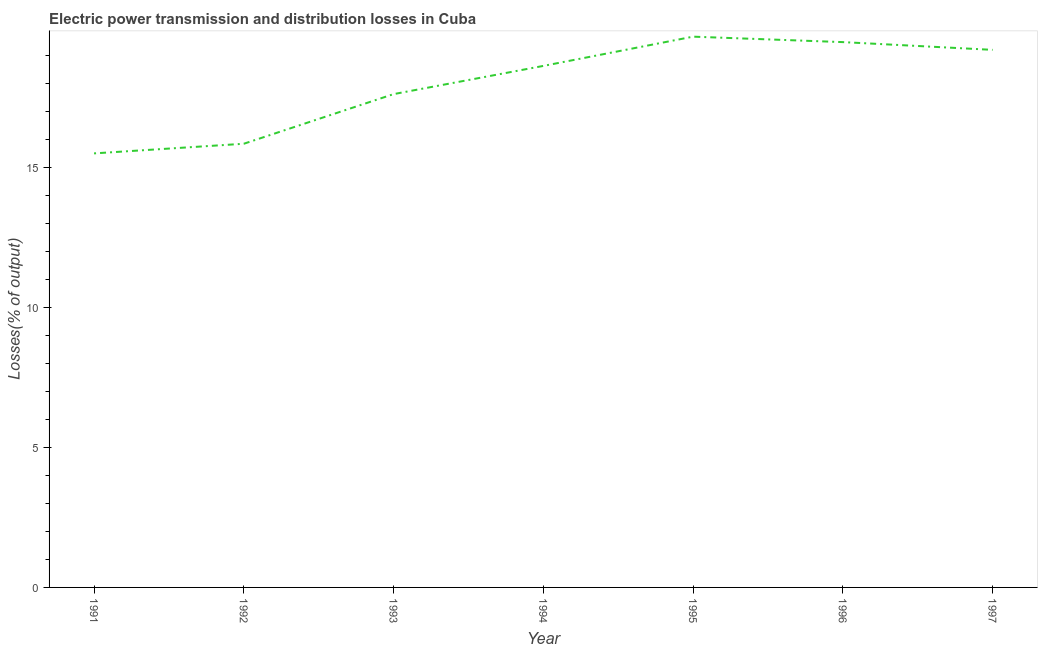What is the electric power transmission and distribution losses in 1993?
Your response must be concise. 17.61. Across all years, what is the maximum electric power transmission and distribution losses?
Make the answer very short. 19.66. Across all years, what is the minimum electric power transmission and distribution losses?
Make the answer very short. 15.49. In which year was the electric power transmission and distribution losses maximum?
Give a very brief answer. 1995. In which year was the electric power transmission and distribution losses minimum?
Give a very brief answer. 1991. What is the sum of the electric power transmission and distribution losses?
Your answer should be compact. 125.85. What is the difference between the electric power transmission and distribution losses in 1994 and 1996?
Provide a succinct answer. -0.85. What is the average electric power transmission and distribution losses per year?
Offer a very short reply. 17.98. What is the median electric power transmission and distribution losses?
Provide a short and direct response. 18.61. Do a majority of the years between 1995 and 1993 (inclusive) have electric power transmission and distribution losses greater than 15 %?
Ensure brevity in your answer.  No. What is the ratio of the electric power transmission and distribution losses in 1993 to that in 1996?
Provide a succinct answer. 0.9. Is the electric power transmission and distribution losses in 1994 less than that in 1997?
Make the answer very short. Yes. What is the difference between the highest and the second highest electric power transmission and distribution losses?
Offer a terse response. 0.19. What is the difference between the highest and the lowest electric power transmission and distribution losses?
Make the answer very short. 4.17. How many lines are there?
Give a very brief answer. 1. Are the values on the major ticks of Y-axis written in scientific E-notation?
Provide a succinct answer. No. Does the graph contain any zero values?
Ensure brevity in your answer.  No. Does the graph contain grids?
Offer a terse response. No. What is the title of the graph?
Keep it short and to the point. Electric power transmission and distribution losses in Cuba. What is the label or title of the X-axis?
Provide a short and direct response. Year. What is the label or title of the Y-axis?
Your response must be concise. Losses(% of output). What is the Losses(% of output) of 1991?
Ensure brevity in your answer.  15.49. What is the Losses(% of output) in 1992?
Make the answer very short. 15.83. What is the Losses(% of output) of 1993?
Your answer should be compact. 17.61. What is the Losses(% of output) of 1994?
Your answer should be very brief. 18.61. What is the Losses(% of output) of 1995?
Make the answer very short. 19.66. What is the Losses(% of output) of 1996?
Offer a terse response. 19.46. What is the Losses(% of output) of 1997?
Provide a short and direct response. 19.19. What is the difference between the Losses(% of output) in 1991 and 1992?
Provide a short and direct response. -0.34. What is the difference between the Losses(% of output) in 1991 and 1993?
Give a very brief answer. -2.12. What is the difference between the Losses(% of output) in 1991 and 1994?
Provide a short and direct response. -3.12. What is the difference between the Losses(% of output) in 1991 and 1995?
Offer a terse response. -4.17. What is the difference between the Losses(% of output) in 1991 and 1996?
Make the answer very short. -3.97. What is the difference between the Losses(% of output) in 1991 and 1997?
Your answer should be very brief. -3.7. What is the difference between the Losses(% of output) in 1992 and 1993?
Offer a very short reply. -1.77. What is the difference between the Losses(% of output) in 1992 and 1994?
Offer a terse response. -2.78. What is the difference between the Losses(% of output) in 1992 and 1995?
Keep it short and to the point. -3.82. What is the difference between the Losses(% of output) in 1992 and 1996?
Your answer should be compact. -3.63. What is the difference between the Losses(% of output) in 1992 and 1997?
Keep it short and to the point. -3.35. What is the difference between the Losses(% of output) in 1993 and 1994?
Give a very brief answer. -1.01. What is the difference between the Losses(% of output) in 1993 and 1995?
Ensure brevity in your answer.  -2.05. What is the difference between the Losses(% of output) in 1993 and 1996?
Offer a very short reply. -1.86. What is the difference between the Losses(% of output) in 1993 and 1997?
Offer a very short reply. -1.58. What is the difference between the Losses(% of output) in 1994 and 1995?
Give a very brief answer. -1.04. What is the difference between the Losses(% of output) in 1994 and 1996?
Keep it short and to the point. -0.85. What is the difference between the Losses(% of output) in 1994 and 1997?
Provide a short and direct response. -0.57. What is the difference between the Losses(% of output) in 1995 and 1996?
Make the answer very short. 0.19. What is the difference between the Losses(% of output) in 1995 and 1997?
Offer a very short reply. 0.47. What is the difference between the Losses(% of output) in 1996 and 1997?
Keep it short and to the point. 0.28. What is the ratio of the Losses(% of output) in 1991 to that in 1992?
Offer a very short reply. 0.98. What is the ratio of the Losses(% of output) in 1991 to that in 1994?
Provide a short and direct response. 0.83. What is the ratio of the Losses(% of output) in 1991 to that in 1995?
Your response must be concise. 0.79. What is the ratio of the Losses(% of output) in 1991 to that in 1996?
Provide a short and direct response. 0.8. What is the ratio of the Losses(% of output) in 1991 to that in 1997?
Offer a very short reply. 0.81. What is the ratio of the Losses(% of output) in 1992 to that in 1993?
Your answer should be compact. 0.9. What is the ratio of the Losses(% of output) in 1992 to that in 1994?
Your answer should be compact. 0.85. What is the ratio of the Losses(% of output) in 1992 to that in 1995?
Offer a very short reply. 0.81. What is the ratio of the Losses(% of output) in 1992 to that in 1996?
Your response must be concise. 0.81. What is the ratio of the Losses(% of output) in 1992 to that in 1997?
Make the answer very short. 0.82. What is the ratio of the Losses(% of output) in 1993 to that in 1994?
Offer a very short reply. 0.95. What is the ratio of the Losses(% of output) in 1993 to that in 1995?
Ensure brevity in your answer.  0.9. What is the ratio of the Losses(% of output) in 1993 to that in 1996?
Provide a succinct answer. 0.91. What is the ratio of the Losses(% of output) in 1993 to that in 1997?
Keep it short and to the point. 0.92. What is the ratio of the Losses(% of output) in 1994 to that in 1995?
Make the answer very short. 0.95. What is the ratio of the Losses(% of output) in 1994 to that in 1996?
Offer a terse response. 0.96. What is the ratio of the Losses(% of output) in 1994 to that in 1997?
Provide a short and direct response. 0.97. What is the ratio of the Losses(% of output) in 1995 to that in 1996?
Make the answer very short. 1.01. What is the ratio of the Losses(% of output) in 1996 to that in 1997?
Ensure brevity in your answer.  1.01. 